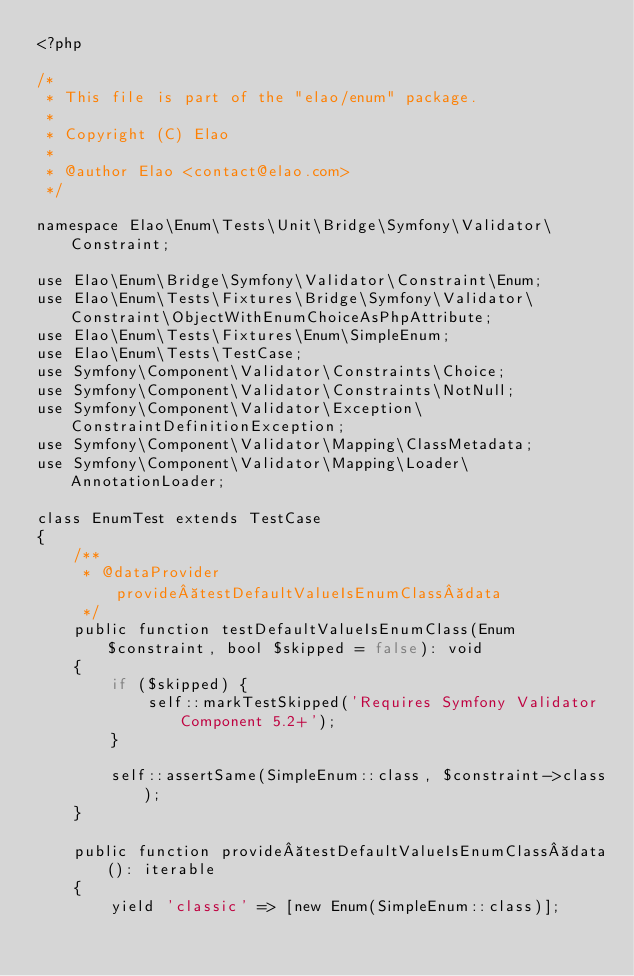<code> <loc_0><loc_0><loc_500><loc_500><_PHP_><?php

/*
 * This file is part of the "elao/enum" package.
 *
 * Copyright (C) Elao
 *
 * @author Elao <contact@elao.com>
 */

namespace Elao\Enum\Tests\Unit\Bridge\Symfony\Validator\Constraint;

use Elao\Enum\Bridge\Symfony\Validator\Constraint\Enum;
use Elao\Enum\Tests\Fixtures\Bridge\Symfony\Validator\Constraint\ObjectWithEnumChoiceAsPhpAttribute;
use Elao\Enum\Tests\Fixtures\Enum\SimpleEnum;
use Elao\Enum\Tests\TestCase;
use Symfony\Component\Validator\Constraints\Choice;
use Symfony\Component\Validator\Constraints\NotNull;
use Symfony\Component\Validator\Exception\ConstraintDefinitionException;
use Symfony\Component\Validator\Mapping\ClassMetadata;
use Symfony\Component\Validator\Mapping\Loader\AnnotationLoader;

class EnumTest extends TestCase
{
    /**
     * @dataProvider provide testDefaultValueIsEnumClass data
     */
    public function testDefaultValueIsEnumClass(Enum $constraint, bool $skipped = false): void
    {
        if ($skipped) {
            self::markTestSkipped('Requires Symfony Validator Component 5.2+');
        }

        self::assertSame(SimpleEnum::class, $constraint->class);
    }

    public function provide testDefaultValueIsEnumClass data(): iterable
    {
        yield 'classic' => [new Enum(SimpleEnum::class)];
</code> 